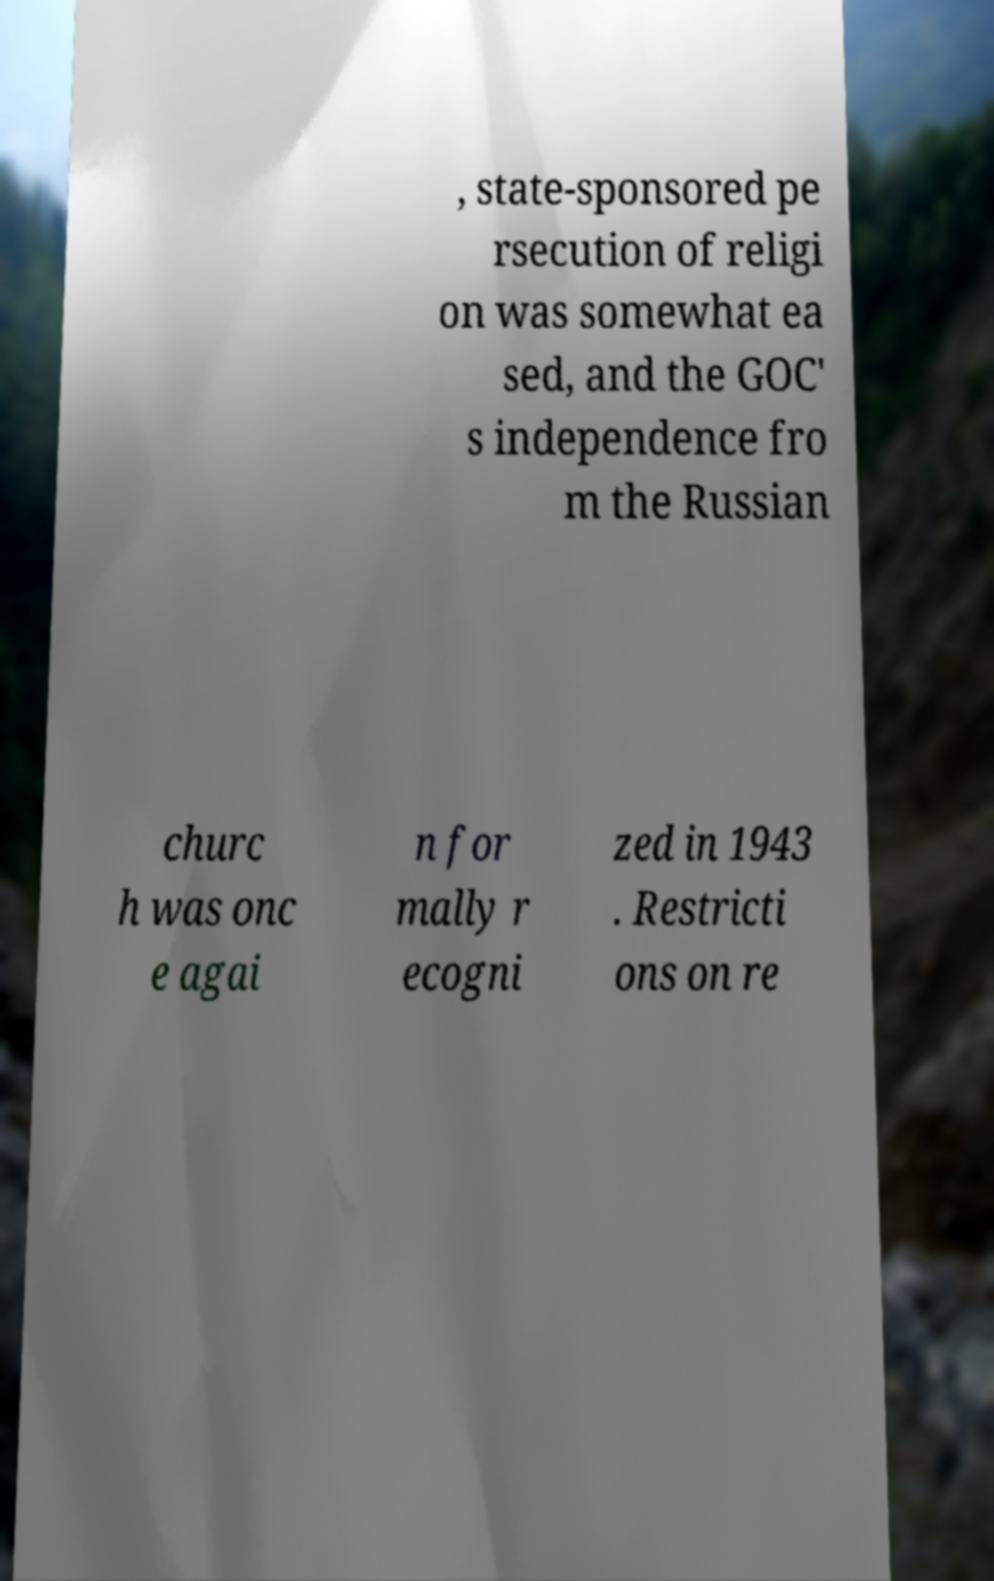What messages or text are displayed in this image? I need them in a readable, typed format. , state-sponsored pe rsecution of religi on was somewhat ea sed, and the GOC' s independence fro m the Russian churc h was onc e agai n for mally r ecogni zed in 1943 . Restricti ons on re 